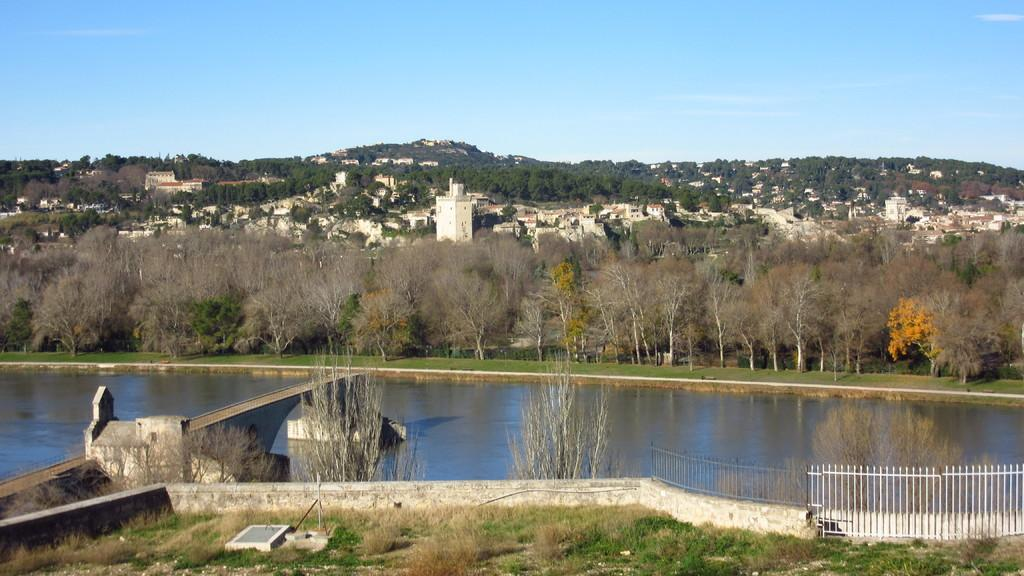What is the main feature in the middle of the picture? There is a lake in the middle of the picture. What can be seen on the right side of the picture? There is a railing on the right side of the picture. What type of vegetation is visible in the background of the picture? There are trees in the background of the picture. What is visible in the background of the picture besides the trees? The sky is visible in the background of the picture. What type of muscle can be seen flexing near the lake in the image? There is no muscle visible in the image; it is a picture of a lake, railing, trees, and sky. How many bags of popcorn are present in the image? There are no bags of popcorn present in the image. 